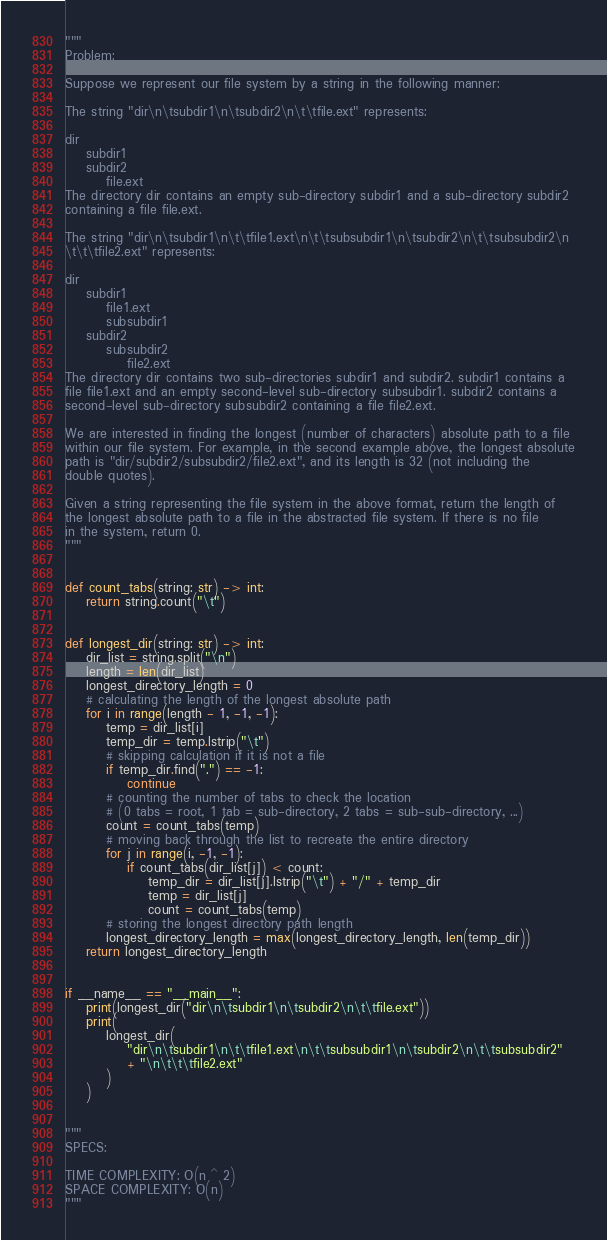Convert code to text. <code><loc_0><loc_0><loc_500><loc_500><_Python_>"""
Problem:

Suppose we represent our file system by a string in the following manner:

The string "dir\n\tsubdir1\n\tsubdir2\n\t\tfile.ext" represents:

dir
    subdir1
    subdir2
        file.ext
The directory dir contains an empty sub-directory subdir1 and a sub-directory subdir2
containing a file file.ext.

The string "dir\n\tsubdir1\n\t\tfile1.ext\n\t\tsubsubdir1\n\tsubdir2\n\t\tsubsubdir2\n
\t\t\tfile2.ext" represents:

dir
    subdir1
        file1.ext
        subsubdir1
    subdir2
        subsubdir2
            file2.ext
The directory dir contains two sub-directories subdir1 and subdir2. subdir1 contains a
file file1.ext and an empty second-level sub-directory subsubdir1. subdir2 contains a
second-level sub-directory subsubdir2 containing a file file2.ext.

We are interested in finding the longest (number of characters) absolute path to a file
within our file system. For example, in the second example above, the longest absolute
path is "dir/subdir2/subsubdir2/file2.ext", and its length is 32 (not including the
double quotes).

Given a string representing the file system in the above format, return the length of
the longest absolute path to a file in the abstracted file system. If there is no file
in the system, return 0.
"""


def count_tabs(string: str) -> int:
    return string.count("\t")


def longest_dir(string: str) -> int:
    dir_list = string.split("\n")
    length = len(dir_list)
    longest_directory_length = 0
    # calculating the length of the longest absolute path
    for i in range(length - 1, -1, -1):
        temp = dir_list[i]
        temp_dir = temp.lstrip("\t")
        # skipping calculation if it is not a file
        if temp_dir.find(".") == -1:
            continue
        # counting the number of tabs to check the location
        # (0 tabs = root, 1 tab = sub-directory, 2 tabs = sub-sub-directory, ...)
        count = count_tabs(temp)
        # moving back through the list to recreate the entire directory
        for j in range(i, -1, -1):
            if count_tabs(dir_list[j]) < count:
                temp_dir = dir_list[j].lstrip("\t") + "/" + temp_dir
                temp = dir_list[j]
                count = count_tabs(temp)
        # storing the longest directory path length
        longest_directory_length = max(longest_directory_length, len(temp_dir))
    return longest_directory_length


if __name__ == "__main__":
    print(longest_dir("dir\n\tsubdir1\n\tsubdir2\n\t\tfile.ext"))
    print(
        longest_dir(
            "dir\n\tsubdir1\n\t\tfile1.ext\n\t\tsubsubdir1\n\tsubdir2\n\t\tsubsubdir2"
            + "\n\t\t\tfile2.ext"
        )
    )


"""
SPECS:

TIME COMPLEXITY: O(n ^ 2)
SPACE COMPLEXITY: O(n)
"""
</code> 